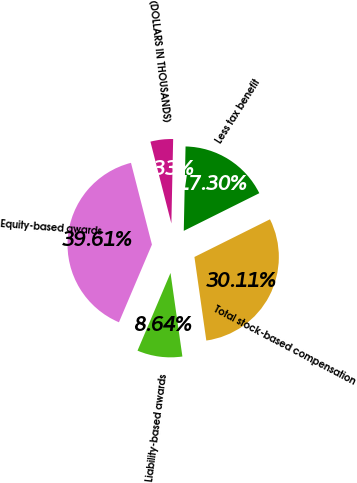<chart> <loc_0><loc_0><loc_500><loc_500><pie_chart><fcel>(DOLLARS IN THOUSANDS)<fcel>Equity-based awards<fcel>Liability-based awards<fcel>Total stock-based compensation<fcel>Less tax benefit<nl><fcel>4.33%<fcel>39.61%<fcel>8.64%<fcel>30.11%<fcel>17.3%<nl></chart> 